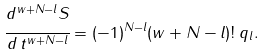Convert formula to latex. <formula><loc_0><loc_0><loc_500><loc_500>\cfrac { d ^ { w + N - l } S } { d \, t ^ { w + N - l } } = ( - 1 ) ^ { N - l } ( w + N - l ) ! \, q _ { l } .</formula> 